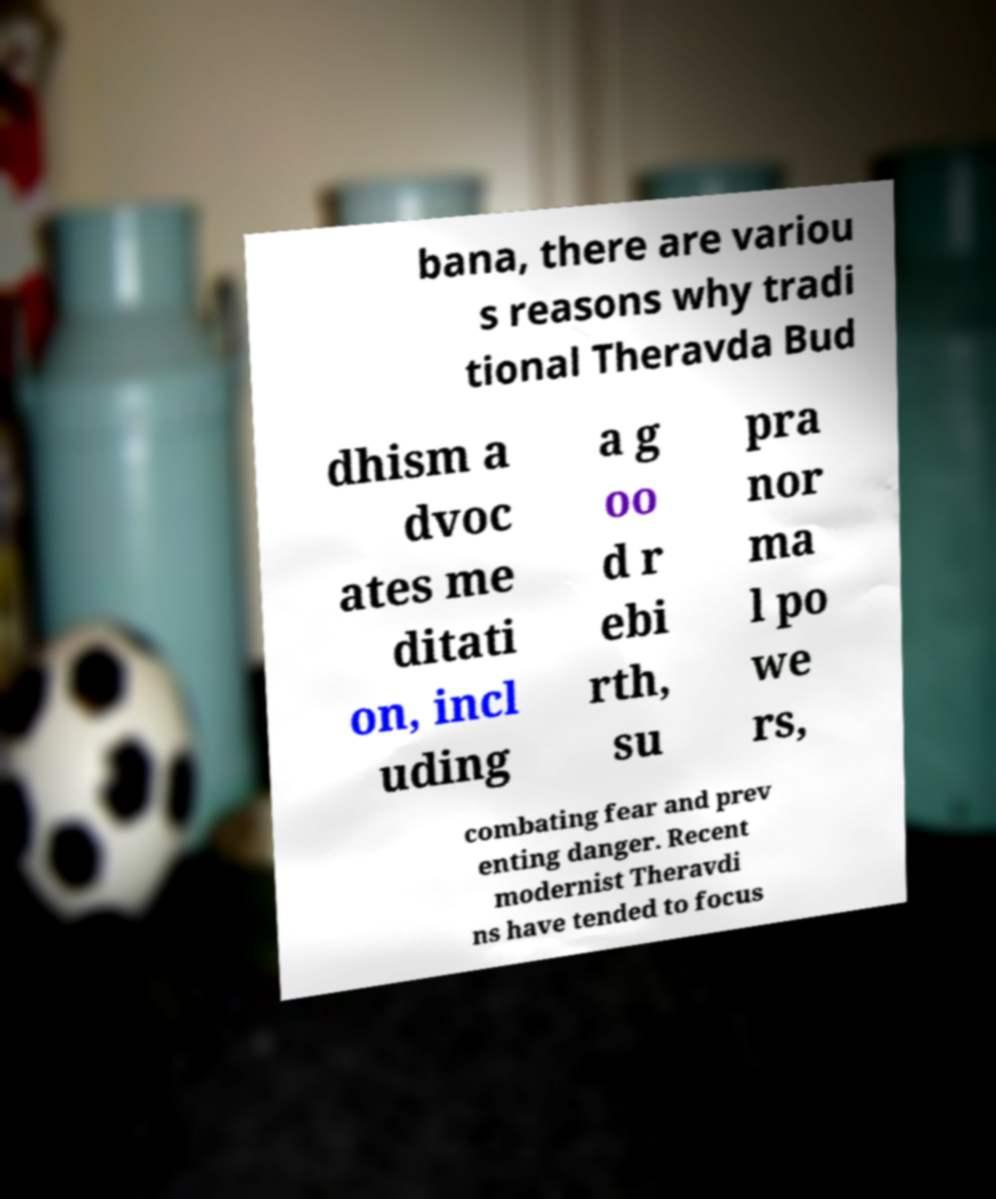Could you assist in decoding the text presented in this image and type it out clearly? bana, there are variou s reasons why tradi tional Theravda Bud dhism a dvoc ates me ditati on, incl uding a g oo d r ebi rth, su pra nor ma l po we rs, combating fear and prev enting danger. Recent modernist Theravdi ns have tended to focus 